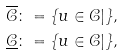<formula> <loc_0><loc_0><loc_500><loc_500>\overline { \mathcal { C } } & \colon = \{ u \in \mathcal { C } | \} , \\ \underline { \mathcal { C } } & \colon = \{ u \in \mathcal { C } | \} , \\</formula> 